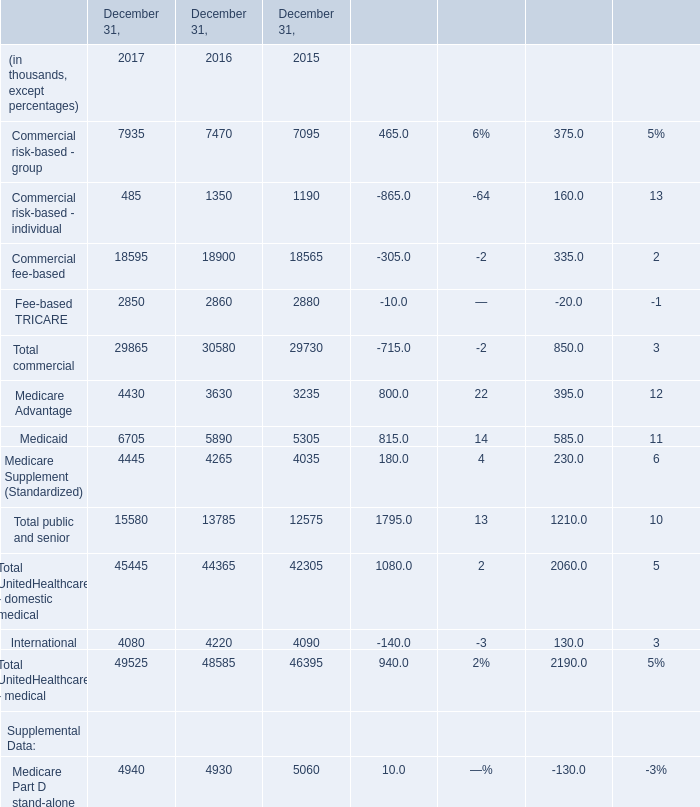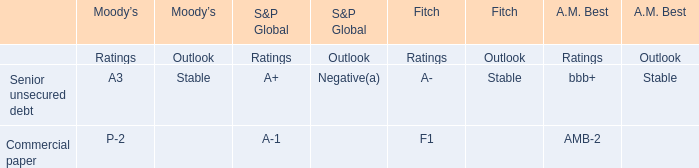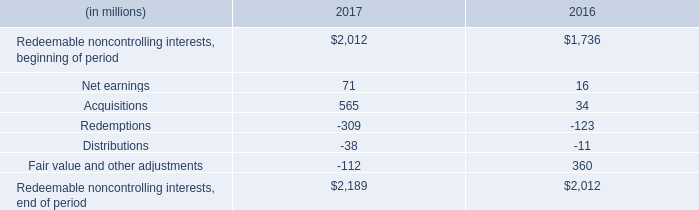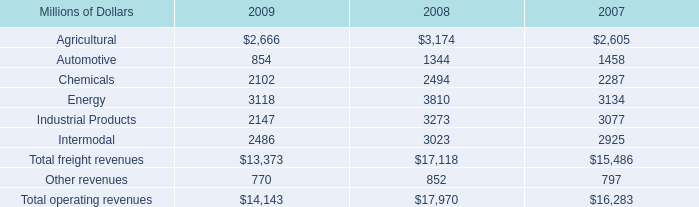what's the total amount of International of December 31, 2016, and Industrial Products of 2007 ? 
Computations: (4220.0 + 3077.0)
Answer: 7297.0. 